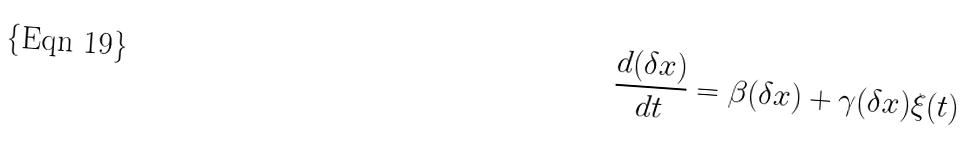<formula> <loc_0><loc_0><loc_500><loc_500>\frac { d ( \delta x ) } { d t } = \beta ( \delta x ) + \gamma ( \delta x ) \xi ( t )</formula> 